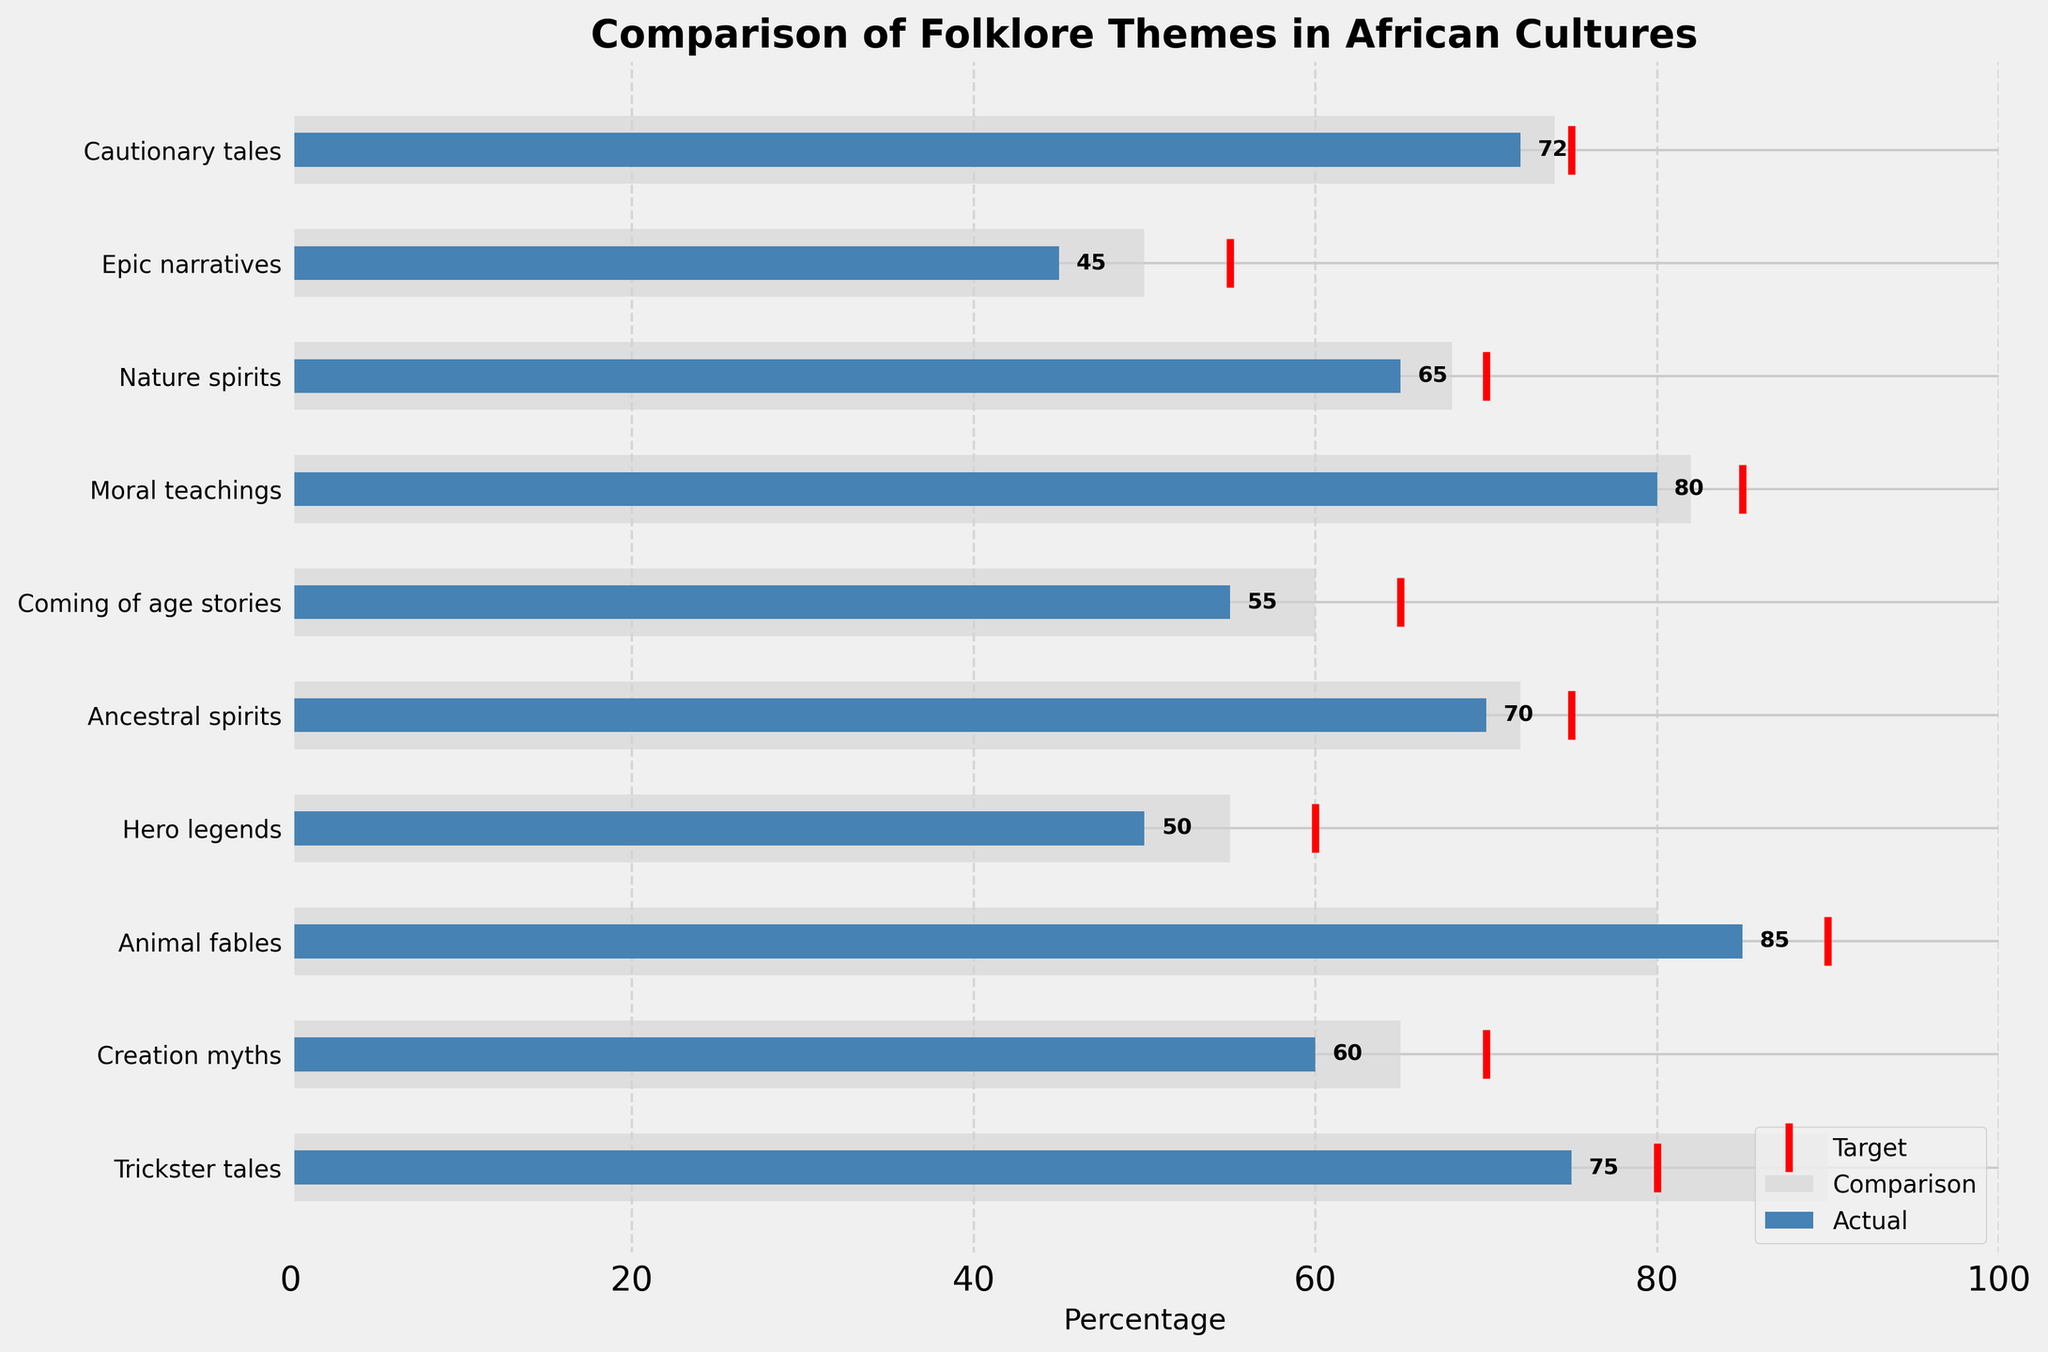Which culture has the highest actual prevalence for trickster tales? The actual prevalence for trickster tales among the Yoruba culture is the longest blue bar in the figure, reaching up to 75%.
Answer: Yoruba What is the target percentage for coming-of-age stories in the Xhosa culture? The red target line for coming-of-age stories in the Xhosa section of the figure aligns at the 65% mark.
Answer: 65% How much difference is there between the actual and target percentages for hero legends in the Maasai culture? The actual percentage for hero legends in Maasai culture is 50%, while the target percentage is 60%. The difference is 60 - 50 = 10%.
Answer: 10% Which theme has the smallest difference between actual and comparison percentages? For all themes, calculate the absolute difference between the actual and comparison percentages. Trickster tales: abs(75-90)=15, Creation myths: abs(60-65)=5, Animal fables: abs(85-80)=5, Hero legends: abs(50-55)=5, Ancestral spirits: abs(70-72)=2, Coming of age stories: abs(55-60)=5, Moral teachings: abs(80-82)=2, Nature spirits: abs(65-68)=3, Epic narratives: abs(45-50)=5, Cautionary tales: abs(72-74)=2. The smallest differences are all equal and occur for Ancestral spirits, Moral teachings, and Cautionary tales, each with a difference of 2.
Answer: Ancestral spirits, Moral teachings, Cautionary tales Which theme in the Akan culture has reached closest to its target percentage? Comparing the actual (85%) and target percentages (90%) for animal fables in the Akan culture, the difference is 5%. Thus, it is 5% away from the target, which is the smallest distance noted per chart details.
Answer: Animal fables Between creation myths in the Zulu culture and hero legends in the Maasai culture, which theme met its target percentage more closely? For creation myths, the target is 70% and the actual is 60%, resulting in a difference of 10%. For hero legends, the target is 60% and the actual is 50%, also with a difference of 10%. Since both differences are equal, neither met its target more closely.
Answer: Neither What is the average target percentage across all themes? Summing all target percentages: 80 + 70 + 90 + 60 + 75 + 65 + 85 + 70 + 55 + 75 = 725. Dividing by the number of themes (10) gives an average target of 72.5%.
Answer: 72.5% What is the mode of the comparison percentages? Examination of the comparison percentages (i.e., 90, 65, 80, 55, 72, 60, 82, 68, 50, 74) shows that no number repeats, hence there is no mode.
Answer: None Which theme has the largest difference between actual and comparison percentages, and what is that difference? Calculating the absolute differences for all themes, the largest difference is for Trickster tales with a difference of abs(75-90)=15%.
Answer: Trickster tales, 15% Between trickster tales (Yoruba) and cautionary tales (Swahili), which has a higher comparison percentage and by how much? Comparison percentage of trickster tales is 90%, and for cautionary tales, it is 74%. The difference is 90 - 74 = 16%.
Answer: Trickster tales, 16% 